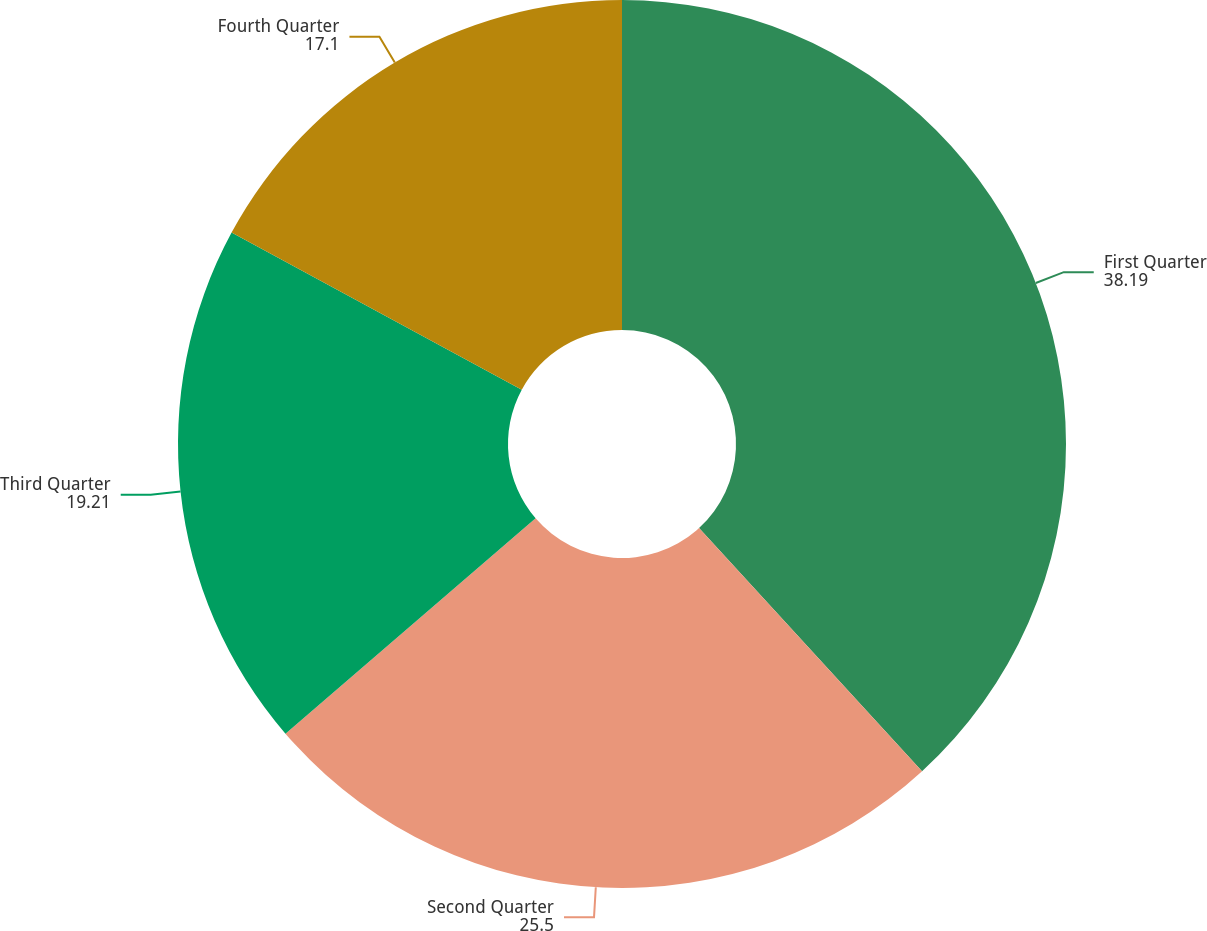Convert chart. <chart><loc_0><loc_0><loc_500><loc_500><pie_chart><fcel>First Quarter<fcel>Second Quarter<fcel>Third Quarter<fcel>Fourth Quarter<nl><fcel>38.19%<fcel>25.5%<fcel>19.21%<fcel>17.1%<nl></chart> 